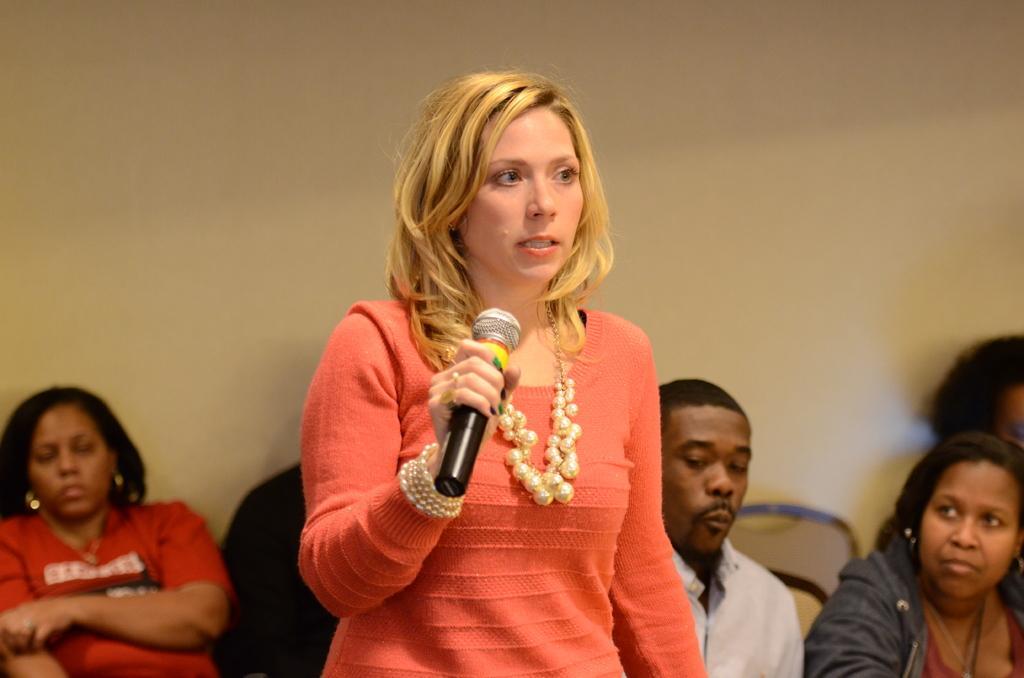In one or two sentences, can you explain what this image depicts? This picture is mainly highlighted with a woman, standing and talking something. This is a mike and the hair colour of this woman is golden in colour. On the background of the picture we can see a wall and few persons are sitting on the chair and on the right side of the picture we can see one women sitting and listening to the speech of this women. 